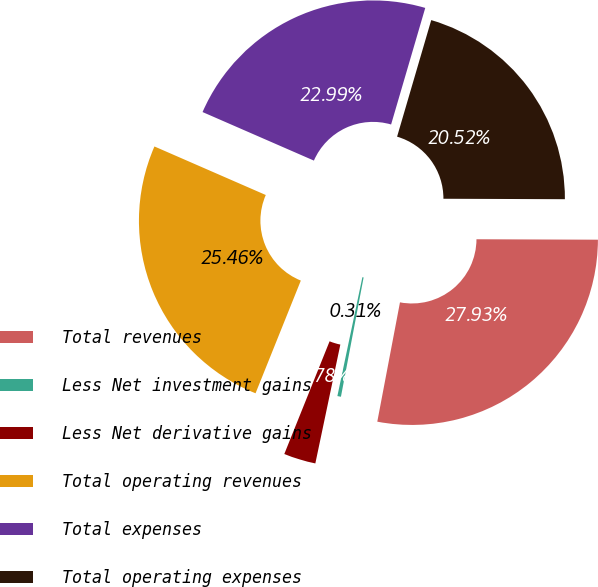Convert chart to OTSL. <chart><loc_0><loc_0><loc_500><loc_500><pie_chart><fcel>Total revenues<fcel>Less Net investment gains<fcel>Less Net derivative gains<fcel>Total operating revenues<fcel>Total expenses<fcel>Total operating expenses<nl><fcel>27.93%<fcel>0.31%<fcel>2.78%<fcel>25.46%<fcel>22.99%<fcel>20.52%<nl></chart> 